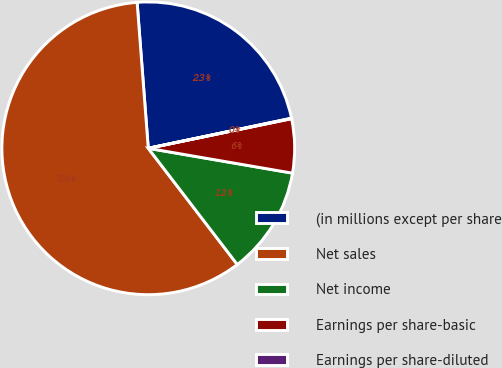Convert chart to OTSL. <chart><loc_0><loc_0><loc_500><loc_500><pie_chart><fcel>(in millions except per share<fcel>Net sales<fcel>Net income<fcel>Earnings per share-basic<fcel>Earnings per share-diluted<nl><fcel>22.92%<fcel>59.19%<fcel>11.88%<fcel>5.96%<fcel>0.05%<nl></chart> 